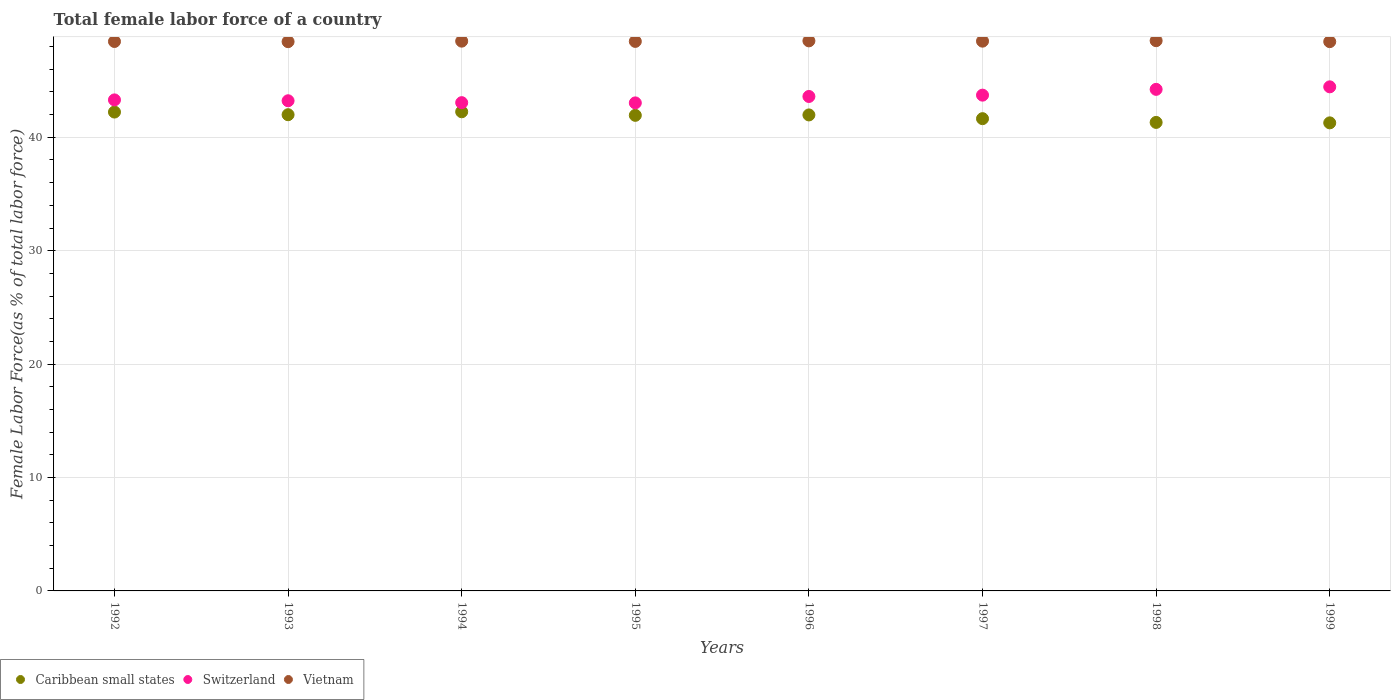Is the number of dotlines equal to the number of legend labels?
Make the answer very short. Yes. What is the percentage of female labor force in Caribbean small states in 1995?
Offer a terse response. 41.93. Across all years, what is the maximum percentage of female labor force in Caribbean small states?
Make the answer very short. 42.25. Across all years, what is the minimum percentage of female labor force in Caribbean small states?
Keep it short and to the point. 41.27. What is the total percentage of female labor force in Switzerland in the graph?
Make the answer very short. 348.59. What is the difference between the percentage of female labor force in Caribbean small states in 1993 and that in 1994?
Make the answer very short. -0.26. What is the difference between the percentage of female labor force in Vietnam in 1998 and the percentage of female labor force in Caribbean small states in 1996?
Ensure brevity in your answer.  6.55. What is the average percentage of female labor force in Vietnam per year?
Provide a succinct answer. 48.47. In the year 1995, what is the difference between the percentage of female labor force in Switzerland and percentage of female labor force in Vietnam?
Your answer should be very brief. -5.42. What is the ratio of the percentage of female labor force in Caribbean small states in 1998 to that in 1999?
Your answer should be compact. 1. What is the difference between the highest and the second highest percentage of female labor force in Vietnam?
Offer a terse response. 0.02. What is the difference between the highest and the lowest percentage of female labor force in Caribbean small states?
Provide a succinct answer. 0.98. In how many years, is the percentage of female labor force in Vietnam greater than the average percentage of female labor force in Vietnam taken over all years?
Your response must be concise. 4. Is the sum of the percentage of female labor force in Caribbean small states in 1992 and 1995 greater than the maximum percentage of female labor force in Vietnam across all years?
Your answer should be very brief. Yes. Is it the case that in every year, the sum of the percentage of female labor force in Vietnam and percentage of female labor force in Caribbean small states  is greater than the percentage of female labor force in Switzerland?
Offer a terse response. Yes. Is the percentage of female labor force in Switzerland strictly greater than the percentage of female labor force in Caribbean small states over the years?
Your response must be concise. Yes. Is the percentage of female labor force in Switzerland strictly less than the percentage of female labor force in Vietnam over the years?
Offer a very short reply. Yes. How many dotlines are there?
Your answer should be very brief. 3. What is the difference between two consecutive major ticks on the Y-axis?
Your answer should be very brief. 10. Are the values on the major ticks of Y-axis written in scientific E-notation?
Make the answer very short. No. Does the graph contain any zero values?
Keep it short and to the point. No. Does the graph contain grids?
Your answer should be compact. Yes. How many legend labels are there?
Provide a succinct answer. 3. What is the title of the graph?
Provide a short and direct response. Total female labor force of a country. What is the label or title of the Y-axis?
Ensure brevity in your answer.  Female Labor Force(as % of total labor force). What is the Female Labor Force(as % of total labor force) of Caribbean small states in 1992?
Provide a succinct answer. 42.22. What is the Female Labor Force(as % of total labor force) in Switzerland in 1992?
Provide a short and direct response. 43.3. What is the Female Labor Force(as % of total labor force) in Vietnam in 1992?
Ensure brevity in your answer.  48.45. What is the Female Labor Force(as % of total labor force) in Caribbean small states in 1993?
Offer a very short reply. 41.99. What is the Female Labor Force(as % of total labor force) in Switzerland in 1993?
Provide a short and direct response. 43.22. What is the Female Labor Force(as % of total labor force) of Vietnam in 1993?
Offer a very short reply. 48.43. What is the Female Labor Force(as % of total labor force) of Caribbean small states in 1994?
Your response must be concise. 42.25. What is the Female Labor Force(as % of total labor force) in Switzerland in 1994?
Keep it short and to the point. 43.05. What is the Female Labor Force(as % of total labor force) of Vietnam in 1994?
Make the answer very short. 48.48. What is the Female Labor Force(as % of total labor force) in Caribbean small states in 1995?
Make the answer very short. 41.93. What is the Female Labor Force(as % of total labor force) in Switzerland in 1995?
Offer a terse response. 43.03. What is the Female Labor Force(as % of total labor force) in Vietnam in 1995?
Offer a terse response. 48.45. What is the Female Labor Force(as % of total labor force) of Caribbean small states in 1996?
Give a very brief answer. 41.97. What is the Female Labor Force(as % of total labor force) of Switzerland in 1996?
Make the answer very short. 43.6. What is the Female Labor Force(as % of total labor force) of Vietnam in 1996?
Provide a succinct answer. 48.5. What is the Female Labor Force(as % of total labor force) of Caribbean small states in 1997?
Provide a succinct answer. 41.64. What is the Female Labor Force(as % of total labor force) in Switzerland in 1997?
Provide a succinct answer. 43.71. What is the Female Labor Force(as % of total labor force) in Vietnam in 1997?
Give a very brief answer. 48.48. What is the Female Labor Force(as % of total labor force) of Caribbean small states in 1998?
Offer a very short reply. 41.31. What is the Female Labor Force(as % of total labor force) of Switzerland in 1998?
Keep it short and to the point. 44.23. What is the Female Labor Force(as % of total labor force) of Vietnam in 1998?
Your answer should be very brief. 48.52. What is the Female Labor Force(as % of total labor force) in Caribbean small states in 1999?
Ensure brevity in your answer.  41.27. What is the Female Labor Force(as % of total labor force) of Switzerland in 1999?
Your answer should be compact. 44.45. What is the Female Labor Force(as % of total labor force) in Vietnam in 1999?
Provide a short and direct response. 48.43. Across all years, what is the maximum Female Labor Force(as % of total labor force) of Caribbean small states?
Your response must be concise. 42.25. Across all years, what is the maximum Female Labor Force(as % of total labor force) of Switzerland?
Ensure brevity in your answer.  44.45. Across all years, what is the maximum Female Labor Force(as % of total labor force) of Vietnam?
Give a very brief answer. 48.52. Across all years, what is the minimum Female Labor Force(as % of total labor force) of Caribbean small states?
Give a very brief answer. 41.27. Across all years, what is the minimum Female Labor Force(as % of total labor force) of Switzerland?
Your answer should be compact. 43.03. Across all years, what is the minimum Female Labor Force(as % of total labor force) of Vietnam?
Offer a terse response. 48.43. What is the total Female Labor Force(as % of total labor force) of Caribbean small states in the graph?
Your answer should be very brief. 334.59. What is the total Female Labor Force(as % of total labor force) in Switzerland in the graph?
Your answer should be compact. 348.59. What is the total Female Labor Force(as % of total labor force) in Vietnam in the graph?
Ensure brevity in your answer.  387.73. What is the difference between the Female Labor Force(as % of total labor force) of Caribbean small states in 1992 and that in 1993?
Keep it short and to the point. 0.23. What is the difference between the Female Labor Force(as % of total labor force) in Switzerland in 1992 and that in 1993?
Offer a very short reply. 0.08. What is the difference between the Female Labor Force(as % of total labor force) of Vietnam in 1992 and that in 1993?
Make the answer very short. 0.01. What is the difference between the Female Labor Force(as % of total labor force) of Caribbean small states in 1992 and that in 1994?
Make the answer very short. -0.03. What is the difference between the Female Labor Force(as % of total labor force) of Switzerland in 1992 and that in 1994?
Provide a short and direct response. 0.24. What is the difference between the Female Labor Force(as % of total labor force) in Vietnam in 1992 and that in 1994?
Your response must be concise. -0.03. What is the difference between the Female Labor Force(as % of total labor force) in Caribbean small states in 1992 and that in 1995?
Give a very brief answer. 0.29. What is the difference between the Female Labor Force(as % of total labor force) in Switzerland in 1992 and that in 1995?
Provide a short and direct response. 0.26. What is the difference between the Female Labor Force(as % of total labor force) in Vietnam in 1992 and that in 1995?
Your answer should be compact. -0.01. What is the difference between the Female Labor Force(as % of total labor force) of Caribbean small states in 1992 and that in 1996?
Ensure brevity in your answer.  0.25. What is the difference between the Female Labor Force(as % of total labor force) of Switzerland in 1992 and that in 1996?
Keep it short and to the point. -0.3. What is the difference between the Female Labor Force(as % of total labor force) of Vietnam in 1992 and that in 1996?
Your answer should be very brief. -0.05. What is the difference between the Female Labor Force(as % of total labor force) of Caribbean small states in 1992 and that in 1997?
Make the answer very short. 0.58. What is the difference between the Female Labor Force(as % of total labor force) of Switzerland in 1992 and that in 1997?
Make the answer very short. -0.42. What is the difference between the Female Labor Force(as % of total labor force) in Vietnam in 1992 and that in 1997?
Offer a terse response. -0.03. What is the difference between the Female Labor Force(as % of total labor force) of Caribbean small states in 1992 and that in 1998?
Make the answer very short. 0.91. What is the difference between the Female Labor Force(as % of total labor force) in Switzerland in 1992 and that in 1998?
Your response must be concise. -0.93. What is the difference between the Female Labor Force(as % of total labor force) in Vietnam in 1992 and that in 1998?
Ensure brevity in your answer.  -0.07. What is the difference between the Female Labor Force(as % of total labor force) in Caribbean small states in 1992 and that in 1999?
Your response must be concise. 0.95. What is the difference between the Female Labor Force(as % of total labor force) in Switzerland in 1992 and that in 1999?
Keep it short and to the point. -1.15. What is the difference between the Female Labor Force(as % of total labor force) in Vietnam in 1992 and that in 1999?
Provide a short and direct response. 0.01. What is the difference between the Female Labor Force(as % of total labor force) of Caribbean small states in 1993 and that in 1994?
Your answer should be compact. -0.26. What is the difference between the Female Labor Force(as % of total labor force) of Switzerland in 1993 and that in 1994?
Make the answer very short. 0.17. What is the difference between the Female Labor Force(as % of total labor force) of Vietnam in 1993 and that in 1994?
Provide a succinct answer. -0.05. What is the difference between the Female Labor Force(as % of total labor force) of Caribbean small states in 1993 and that in 1995?
Give a very brief answer. 0.06. What is the difference between the Female Labor Force(as % of total labor force) in Switzerland in 1993 and that in 1995?
Provide a succinct answer. 0.19. What is the difference between the Female Labor Force(as % of total labor force) in Vietnam in 1993 and that in 1995?
Your answer should be very brief. -0.02. What is the difference between the Female Labor Force(as % of total labor force) in Caribbean small states in 1993 and that in 1996?
Keep it short and to the point. 0.02. What is the difference between the Female Labor Force(as % of total labor force) of Switzerland in 1993 and that in 1996?
Your answer should be compact. -0.38. What is the difference between the Female Labor Force(as % of total labor force) of Vietnam in 1993 and that in 1996?
Your answer should be compact. -0.07. What is the difference between the Female Labor Force(as % of total labor force) of Caribbean small states in 1993 and that in 1997?
Offer a very short reply. 0.35. What is the difference between the Female Labor Force(as % of total labor force) of Switzerland in 1993 and that in 1997?
Your answer should be very brief. -0.5. What is the difference between the Female Labor Force(as % of total labor force) in Vietnam in 1993 and that in 1997?
Your answer should be very brief. -0.04. What is the difference between the Female Labor Force(as % of total labor force) in Caribbean small states in 1993 and that in 1998?
Provide a short and direct response. 0.68. What is the difference between the Female Labor Force(as % of total labor force) in Switzerland in 1993 and that in 1998?
Your response must be concise. -1.01. What is the difference between the Female Labor Force(as % of total labor force) in Vietnam in 1993 and that in 1998?
Keep it short and to the point. -0.09. What is the difference between the Female Labor Force(as % of total labor force) of Caribbean small states in 1993 and that in 1999?
Provide a succinct answer. 0.72. What is the difference between the Female Labor Force(as % of total labor force) in Switzerland in 1993 and that in 1999?
Offer a terse response. -1.23. What is the difference between the Female Labor Force(as % of total labor force) of Vietnam in 1993 and that in 1999?
Your response must be concise. -0. What is the difference between the Female Labor Force(as % of total labor force) of Caribbean small states in 1994 and that in 1995?
Provide a succinct answer. 0.31. What is the difference between the Female Labor Force(as % of total labor force) of Switzerland in 1994 and that in 1995?
Give a very brief answer. 0.02. What is the difference between the Female Labor Force(as % of total labor force) in Vietnam in 1994 and that in 1995?
Your response must be concise. 0.02. What is the difference between the Female Labor Force(as % of total labor force) of Caribbean small states in 1994 and that in 1996?
Your answer should be compact. 0.28. What is the difference between the Female Labor Force(as % of total labor force) of Switzerland in 1994 and that in 1996?
Provide a succinct answer. -0.55. What is the difference between the Female Labor Force(as % of total labor force) of Vietnam in 1994 and that in 1996?
Give a very brief answer. -0.02. What is the difference between the Female Labor Force(as % of total labor force) of Caribbean small states in 1994 and that in 1997?
Offer a very short reply. 0.61. What is the difference between the Female Labor Force(as % of total labor force) in Switzerland in 1994 and that in 1997?
Keep it short and to the point. -0.66. What is the difference between the Female Labor Force(as % of total labor force) of Vietnam in 1994 and that in 1997?
Keep it short and to the point. 0. What is the difference between the Female Labor Force(as % of total labor force) in Caribbean small states in 1994 and that in 1998?
Give a very brief answer. 0.94. What is the difference between the Female Labor Force(as % of total labor force) of Switzerland in 1994 and that in 1998?
Provide a short and direct response. -1.17. What is the difference between the Female Labor Force(as % of total labor force) of Vietnam in 1994 and that in 1998?
Your response must be concise. -0.04. What is the difference between the Female Labor Force(as % of total labor force) of Caribbean small states in 1994 and that in 1999?
Give a very brief answer. 0.98. What is the difference between the Female Labor Force(as % of total labor force) in Switzerland in 1994 and that in 1999?
Your response must be concise. -1.4. What is the difference between the Female Labor Force(as % of total labor force) in Vietnam in 1994 and that in 1999?
Your answer should be very brief. 0.04. What is the difference between the Female Labor Force(as % of total labor force) of Caribbean small states in 1995 and that in 1996?
Your answer should be very brief. -0.04. What is the difference between the Female Labor Force(as % of total labor force) of Switzerland in 1995 and that in 1996?
Make the answer very short. -0.57. What is the difference between the Female Labor Force(as % of total labor force) in Vietnam in 1995 and that in 1996?
Offer a very short reply. -0.05. What is the difference between the Female Labor Force(as % of total labor force) in Caribbean small states in 1995 and that in 1997?
Provide a succinct answer. 0.29. What is the difference between the Female Labor Force(as % of total labor force) in Switzerland in 1995 and that in 1997?
Your answer should be compact. -0.68. What is the difference between the Female Labor Force(as % of total labor force) in Vietnam in 1995 and that in 1997?
Provide a short and direct response. -0.02. What is the difference between the Female Labor Force(as % of total labor force) in Caribbean small states in 1995 and that in 1998?
Ensure brevity in your answer.  0.62. What is the difference between the Female Labor Force(as % of total labor force) in Switzerland in 1995 and that in 1998?
Provide a short and direct response. -1.19. What is the difference between the Female Labor Force(as % of total labor force) of Vietnam in 1995 and that in 1998?
Your answer should be very brief. -0.06. What is the difference between the Female Labor Force(as % of total labor force) in Caribbean small states in 1995 and that in 1999?
Keep it short and to the point. 0.66. What is the difference between the Female Labor Force(as % of total labor force) of Switzerland in 1995 and that in 1999?
Offer a terse response. -1.42. What is the difference between the Female Labor Force(as % of total labor force) of Vietnam in 1995 and that in 1999?
Offer a very short reply. 0.02. What is the difference between the Female Labor Force(as % of total labor force) of Caribbean small states in 1996 and that in 1997?
Your answer should be very brief. 0.33. What is the difference between the Female Labor Force(as % of total labor force) of Switzerland in 1996 and that in 1997?
Your answer should be compact. -0.12. What is the difference between the Female Labor Force(as % of total labor force) in Vietnam in 1996 and that in 1997?
Ensure brevity in your answer.  0.03. What is the difference between the Female Labor Force(as % of total labor force) of Caribbean small states in 1996 and that in 1998?
Ensure brevity in your answer.  0.66. What is the difference between the Female Labor Force(as % of total labor force) of Switzerland in 1996 and that in 1998?
Ensure brevity in your answer.  -0.63. What is the difference between the Female Labor Force(as % of total labor force) of Vietnam in 1996 and that in 1998?
Your response must be concise. -0.02. What is the difference between the Female Labor Force(as % of total labor force) of Caribbean small states in 1996 and that in 1999?
Give a very brief answer. 0.7. What is the difference between the Female Labor Force(as % of total labor force) of Switzerland in 1996 and that in 1999?
Make the answer very short. -0.85. What is the difference between the Female Labor Force(as % of total labor force) of Vietnam in 1996 and that in 1999?
Your answer should be compact. 0.07. What is the difference between the Female Labor Force(as % of total labor force) of Caribbean small states in 1997 and that in 1998?
Offer a very short reply. 0.33. What is the difference between the Female Labor Force(as % of total labor force) of Switzerland in 1997 and that in 1998?
Your response must be concise. -0.51. What is the difference between the Female Labor Force(as % of total labor force) in Vietnam in 1997 and that in 1998?
Provide a short and direct response. -0.04. What is the difference between the Female Labor Force(as % of total labor force) in Caribbean small states in 1997 and that in 1999?
Make the answer very short. 0.37. What is the difference between the Female Labor Force(as % of total labor force) of Switzerland in 1997 and that in 1999?
Your response must be concise. -0.73. What is the difference between the Female Labor Force(as % of total labor force) in Vietnam in 1997 and that in 1999?
Provide a short and direct response. 0.04. What is the difference between the Female Labor Force(as % of total labor force) of Caribbean small states in 1998 and that in 1999?
Keep it short and to the point. 0.04. What is the difference between the Female Labor Force(as % of total labor force) of Switzerland in 1998 and that in 1999?
Give a very brief answer. -0.22. What is the difference between the Female Labor Force(as % of total labor force) in Vietnam in 1998 and that in 1999?
Offer a terse response. 0.09. What is the difference between the Female Labor Force(as % of total labor force) in Caribbean small states in 1992 and the Female Labor Force(as % of total labor force) in Switzerland in 1993?
Your answer should be compact. -1. What is the difference between the Female Labor Force(as % of total labor force) of Caribbean small states in 1992 and the Female Labor Force(as % of total labor force) of Vietnam in 1993?
Your response must be concise. -6.21. What is the difference between the Female Labor Force(as % of total labor force) of Switzerland in 1992 and the Female Labor Force(as % of total labor force) of Vietnam in 1993?
Provide a short and direct response. -5.13. What is the difference between the Female Labor Force(as % of total labor force) in Caribbean small states in 1992 and the Female Labor Force(as % of total labor force) in Switzerland in 1994?
Offer a very short reply. -0.83. What is the difference between the Female Labor Force(as % of total labor force) in Caribbean small states in 1992 and the Female Labor Force(as % of total labor force) in Vietnam in 1994?
Ensure brevity in your answer.  -6.25. What is the difference between the Female Labor Force(as % of total labor force) in Switzerland in 1992 and the Female Labor Force(as % of total labor force) in Vietnam in 1994?
Your answer should be compact. -5.18. What is the difference between the Female Labor Force(as % of total labor force) of Caribbean small states in 1992 and the Female Labor Force(as % of total labor force) of Switzerland in 1995?
Your response must be concise. -0.81. What is the difference between the Female Labor Force(as % of total labor force) of Caribbean small states in 1992 and the Female Labor Force(as % of total labor force) of Vietnam in 1995?
Your answer should be very brief. -6.23. What is the difference between the Female Labor Force(as % of total labor force) of Switzerland in 1992 and the Female Labor Force(as % of total labor force) of Vietnam in 1995?
Offer a terse response. -5.16. What is the difference between the Female Labor Force(as % of total labor force) in Caribbean small states in 1992 and the Female Labor Force(as % of total labor force) in Switzerland in 1996?
Offer a terse response. -1.37. What is the difference between the Female Labor Force(as % of total labor force) of Caribbean small states in 1992 and the Female Labor Force(as % of total labor force) of Vietnam in 1996?
Provide a succinct answer. -6.28. What is the difference between the Female Labor Force(as % of total labor force) in Switzerland in 1992 and the Female Labor Force(as % of total labor force) in Vietnam in 1996?
Provide a succinct answer. -5.2. What is the difference between the Female Labor Force(as % of total labor force) of Caribbean small states in 1992 and the Female Labor Force(as % of total labor force) of Switzerland in 1997?
Keep it short and to the point. -1.49. What is the difference between the Female Labor Force(as % of total labor force) in Caribbean small states in 1992 and the Female Labor Force(as % of total labor force) in Vietnam in 1997?
Make the answer very short. -6.25. What is the difference between the Female Labor Force(as % of total labor force) of Switzerland in 1992 and the Female Labor Force(as % of total labor force) of Vietnam in 1997?
Your answer should be very brief. -5.18. What is the difference between the Female Labor Force(as % of total labor force) in Caribbean small states in 1992 and the Female Labor Force(as % of total labor force) in Switzerland in 1998?
Keep it short and to the point. -2. What is the difference between the Female Labor Force(as % of total labor force) of Caribbean small states in 1992 and the Female Labor Force(as % of total labor force) of Vietnam in 1998?
Provide a short and direct response. -6.29. What is the difference between the Female Labor Force(as % of total labor force) in Switzerland in 1992 and the Female Labor Force(as % of total labor force) in Vietnam in 1998?
Keep it short and to the point. -5.22. What is the difference between the Female Labor Force(as % of total labor force) of Caribbean small states in 1992 and the Female Labor Force(as % of total labor force) of Switzerland in 1999?
Offer a very short reply. -2.22. What is the difference between the Female Labor Force(as % of total labor force) in Caribbean small states in 1992 and the Female Labor Force(as % of total labor force) in Vietnam in 1999?
Offer a very short reply. -6.21. What is the difference between the Female Labor Force(as % of total labor force) in Switzerland in 1992 and the Female Labor Force(as % of total labor force) in Vietnam in 1999?
Give a very brief answer. -5.14. What is the difference between the Female Labor Force(as % of total labor force) in Caribbean small states in 1993 and the Female Labor Force(as % of total labor force) in Switzerland in 1994?
Ensure brevity in your answer.  -1.06. What is the difference between the Female Labor Force(as % of total labor force) in Caribbean small states in 1993 and the Female Labor Force(as % of total labor force) in Vietnam in 1994?
Ensure brevity in your answer.  -6.49. What is the difference between the Female Labor Force(as % of total labor force) of Switzerland in 1993 and the Female Labor Force(as % of total labor force) of Vietnam in 1994?
Provide a succinct answer. -5.26. What is the difference between the Female Labor Force(as % of total labor force) of Caribbean small states in 1993 and the Female Labor Force(as % of total labor force) of Switzerland in 1995?
Ensure brevity in your answer.  -1.04. What is the difference between the Female Labor Force(as % of total labor force) in Caribbean small states in 1993 and the Female Labor Force(as % of total labor force) in Vietnam in 1995?
Offer a terse response. -6.46. What is the difference between the Female Labor Force(as % of total labor force) of Switzerland in 1993 and the Female Labor Force(as % of total labor force) of Vietnam in 1995?
Your response must be concise. -5.23. What is the difference between the Female Labor Force(as % of total labor force) of Caribbean small states in 1993 and the Female Labor Force(as % of total labor force) of Switzerland in 1996?
Give a very brief answer. -1.61. What is the difference between the Female Labor Force(as % of total labor force) of Caribbean small states in 1993 and the Female Labor Force(as % of total labor force) of Vietnam in 1996?
Offer a terse response. -6.51. What is the difference between the Female Labor Force(as % of total labor force) of Switzerland in 1993 and the Female Labor Force(as % of total labor force) of Vietnam in 1996?
Your answer should be compact. -5.28. What is the difference between the Female Labor Force(as % of total labor force) in Caribbean small states in 1993 and the Female Labor Force(as % of total labor force) in Switzerland in 1997?
Your answer should be compact. -1.72. What is the difference between the Female Labor Force(as % of total labor force) in Caribbean small states in 1993 and the Female Labor Force(as % of total labor force) in Vietnam in 1997?
Provide a succinct answer. -6.49. What is the difference between the Female Labor Force(as % of total labor force) in Switzerland in 1993 and the Female Labor Force(as % of total labor force) in Vietnam in 1997?
Your answer should be very brief. -5.26. What is the difference between the Female Labor Force(as % of total labor force) of Caribbean small states in 1993 and the Female Labor Force(as % of total labor force) of Switzerland in 1998?
Provide a succinct answer. -2.24. What is the difference between the Female Labor Force(as % of total labor force) in Caribbean small states in 1993 and the Female Labor Force(as % of total labor force) in Vietnam in 1998?
Offer a terse response. -6.53. What is the difference between the Female Labor Force(as % of total labor force) of Switzerland in 1993 and the Female Labor Force(as % of total labor force) of Vietnam in 1998?
Your response must be concise. -5.3. What is the difference between the Female Labor Force(as % of total labor force) in Caribbean small states in 1993 and the Female Labor Force(as % of total labor force) in Switzerland in 1999?
Your response must be concise. -2.46. What is the difference between the Female Labor Force(as % of total labor force) in Caribbean small states in 1993 and the Female Labor Force(as % of total labor force) in Vietnam in 1999?
Keep it short and to the point. -6.44. What is the difference between the Female Labor Force(as % of total labor force) in Switzerland in 1993 and the Female Labor Force(as % of total labor force) in Vietnam in 1999?
Provide a succinct answer. -5.21. What is the difference between the Female Labor Force(as % of total labor force) of Caribbean small states in 1994 and the Female Labor Force(as % of total labor force) of Switzerland in 1995?
Your response must be concise. -0.78. What is the difference between the Female Labor Force(as % of total labor force) in Caribbean small states in 1994 and the Female Labor Force(as % of total labor force) in Vietnam in 1995?
Your response must be concise. -6.2. What is the difference between the Female Labor Force(as % of total labor force) of Switzerland in 1994 and the Female Labor Force(as % of total labor force) of Vietnam in 1995?
Make the answer very short. -5.4. What is the difference between the Female Labor Force(as % of total labor force) of Caribbean small states in 1994 and the Female Labor Force(as % of total labor force) of Switzerland in 1996?
Ensure brevity in your answer.  -1.35. What is the difference between the Female Labor Force(as % of total labor force) in Caribbean small states in 1994 and the Female Labor Force(as % of total labor force) in Vietnam in 1996?
Provide a succinct answer. -6.25. What is the difference between the Female Labor Force(as % of total labor force) of Switzerland in 1994 and the Female Labor Force(as % of total labor force) of Vietnam in 1996?
Offer a terse response. -5.45. What is the difference between the Female Labor Force(as % of total labor force) of Caribbean small states in 1994 and the Female Labor Force(as % of total labor force) of Switzerland in 1997?
Your answer should be compact. -1.47. What is the difference between the Female Labor Force(as % of total labor force) in Caribbean small states in 1994 and the Female Labor Force(as % of total labor force) in Vietnam in 1997?
Your answer should be compact. -6.23. What is the difference between the Female Labor Force(as % of total labor force) in Switzerland in 1994 and the Female Labor Force(as % of total labor force) in Vietnam in 1997?
Make the answer very short. -5.42. What is the difference between the Female Labor Force(as % of total labor force) of Caribbean small states in 1994 and the Female Labor Force(as % of total labor force) of Switzerland in 1998?
Provide a succinct answer. -1.98. What is the difference between the Female Labor Force(as % of total labor force) in Caribbean small states in 1994 and the Female Labor Force(as % of total labor force) in Vietnam in 1998?
Offer a terse response. -6.27. What is the difference between the Female Labor Force(as % of total labor force) in Switzerland in 1994 and the Female Labor Force(as % of total labor force) in Vietnam in 1998?
Keep it short and to the point. -5.46. What is the difference between the Female Labor Force(as % of total labor force) of Caribbean small states in 1994 and the Female Labor Force(as % of total labor force) of Switzerland in 1999?
Provide a short and direct response. -2.2. What is the difference between the Female Labor Force(as % of total labor force) in Caribbean small states in 1994 and the Female Labor Force(as % of total labor force) in Vietnam in 1999?
Your answer should be compact. -6.18. What is the difference between the Female Labor Force(as % of total labor force) of Switzerland in 1994 and the Female Labor Force(as % of total labor force) of Vietnam in 1999?
Give a very brief answer. -5.38. What is the difference between the Female Labor Force(as % of total labor force) of Caribbean small states in 1995 and the Female Labor Force(as % of total labor force) of Switzerland in 1996?
Your answer should be compact. -1.66. What is the difference between the Female Labor Force(as % of total labor force) of Caribbean small states in 1995 and the Female Labor Force(as % of total labor force) of Vietnam in 1996?
Provide a short and direct response. -6.57. What is the difference between the Female Labor Force(as % of total labor force) in Switzerland in 1995 and the Female Labor Force(as % of total labor force) in Vietnam in 1996?
Offer a terse response. -5.47. What is the difference between the Female Labor Force(as % of total labor force) in Caribbean small states in 1995 and the Female Labor Force(as % of total labor force) in Switzerland in 1997?
Provide a short and direct response. -1.78. What is the difference between the Female Labor Force(as % of total labor force) in Caribbean small states in 1995 and the Female Labor Force(as % of total labor force) in Vietnam in 1997?
Offer a very short reply. -6.54. What is the difference between the Female Labor Force(as % of total labor force) in Switzerland in 1995 and the Female Labor Force(as % of total labor force) in Vietnam in 1997?
Ensure brevity in your answer.  -5.44. What is the difference between the Female Labor Force(as % of total labor force) in Caribbean small states in 1995 and the Female Labor Force(as % of total labor force) in Switzerland in 1998?
Make the answer very short. -2.29. What is the difference between the Female Labor Force(as % of total labor force) of Caribbean small states in 1995 and the Female Labor Force(as % of total labor force) of Vietnam in 1998?
Offer a very short reply. -6.58. What is the difference between the Female Labor Force(as % of total labor force) in Switzerland in 1995 and the Female Labor Force(as % of total labor force) in Vietnam in 1998?
Make the answer very short. -5.49. What is the difference between the Female Labor Force(as % of total labor force) in Caribbean small states in 1995 and the Female Labor Force(as % of total labor force) in Switzerland in 1999?
Your answer should be compact. -2.51. What is the difference between the Female Labor Force(as % of total labor force) of Caribbean small states in 1995 and the Female Labor Force(as % of total labor force) of Vietnam in 1999?
Offer a terse response. -6.5. What is the difference between the Female Labor Force(as % of total labor force) of Switzerland in 1995 and the Female Labor Force(as % of total labor force) of Vietnam in 1999?
Your response must be concise. -5.4. What is the difference between the Female Labor Force(as % of total labor force) in Caribbean small states in 1996 and the Female Labor Force(as % of total labor force) in Switzerland in 1997?
Your answer should be compact. -1.74. What is the difference between the Female Labor Force(as % of total labor force) in Caribbean small states in 1996 and the Female Labor Force(as % of total labor force) in Vietnam in 1997?
Your answer should be compact. -6.5. What is the difference between the Female Labor Force(as % of total labor force) of Switzerland in 1996 and the Female Labor Force(as % of total labor force) of Vietnam in 1997?
Your response must be concise. -4.88. What is the difference between the Female Labor Force(as % of total labor force) of Caribbean small states in 1996 and the Female Labor Force(as % of total labor force) of Switzerland in 1998?
Provide a succinct answer. -2.26. What is the difference between the Female Labor Force(as % of total labor force) in Caribbean small states in 1996 and the Female Labor Force(as % of total labor force) in Vietnam in 1998?
Make the answer very short. -6.55. What is the difference between the Female Labor Force(as % of total labor force) of Switzerland in 1996 and the Female Labor Force(as % of total labor force) of Vietnam in 1998?
Your answer should be very brief. -4.92. What is the difference between the Female Labor Force(as % of total labor force) of Caribbean small states in 1996 and the Female Labor Force(as % of total labor force) of Switzerland in 1999?
Keep it short and to the point. -2.48. What is the difference between the Female Labor Force(as % of total labor force) in Caribbean small states in 1996 and the Female Labor Force(as % of total labor force) in Vietnam in 1999?
Your answer should be compact. -6.46. What is the difference between the Female Labor Force(as % of total labor force) of Switzerland in 1996 and the Female Labor Force(as % of total labor force) of Vietnam in 1999?
Provide a succinct answer. -4.83. What is the difference between the Female Labor Force(as % of total labor force) of Caribbean small states in 1997 and the Female Labor Force(as % of total labor force) of Switzerland in 1998?
Ensure brevity in your answer.  -2.58. What is the difference between the Female Labor Force(as % of total labor force) of Caribbean small states in 1997 and the Female Labor Force(as % of total labor force) of Vietnam in 1998?
Keep it short and to the point. -6.88. What is the difference between the Female Labor Force(as % of total labor force) in Switzerland in 1997 and the Female Labor Force(as % of total labor force) in Vietnam in 1998?
Provide a succinct answer. -4.8. What is the difference between the Female Labor Force(as % of total labor force) in Caribbean small states in 1997 and the Female Labor Force(as % of total labor force) in Switzerland in 1999?
Your answer should be compact. -2.81. What is the difference between the Female Labor Force(as % of total labor force) in Caribbean small states in 1997 and the Female Labor Force(as % of total labor force) in Vietnam in 1999?
Your answer should be very brief. -6.79. What is the difference between the Female Labor Force(as % of total labor force) of Switzerland in 1997 and the Female Labor Force(as % of total labor force) of Vietnam in 1999?
Ensure brevity in your answer.  -4.72. What is the difference between the Female Labor Force(as % of total labor force) in Caribbean small states in 1998 and the Female Labor Force(as % of total labor force) in Switzerland in 1999?
Provide a short and direct response. -3.14. What is the difference between the Female Labor Force(as % of total labor force) in Caribbean small states in 1998 and the Female Labor Force(as % of total labor force) in Vietnam in 1999?
Offer a terse response. -7.12. What is the difference between the Female Labor Force(as % of total labor force) of Switzerland in 1998 and the Female Labor Force(as % of total labor force) of Vietnam in 1999?
Make the answer very short. -4.21. What is the average Female Labor Force(as % of total labor force) of Caribbean small states per year?
Make the answer very short. 41.82. What is the average Female Labor Force(as % of total labor force) of Switzerland per year?
Keep it short and to the point. 43.57. What is the average Female Labor Force(as % of total labor force) in Vietnam per year?
Provide a succinct answer. 48.47. In the year 1992, what is the difference between the Female Labor Force(as % of total labor force) of Caribbean small states and Female Labor Force(as % of total labor force) of Switzerland?
Provide a short and direct response. -1.07. In the year 1992, what is the difference between the Female Labor Force(as % of total labor force) in Caribbean small states and Female Labor Force(as % of total labor force) in Vietnam?
Keep it short and to the point. -6.22. In the year 1992, what is the difference between the Female Labor Force(as % of total labor force) in Switzerland and Female Labor Force(as % of total labor force) in Vietnam?
Your response must be concise. -5.15. In the year 1993, what is the difference between the Female Labor Force(as % of total labor force) of Caribbean small states and Female Labor Force(as % of total labor force) of Switzerland?
Keep it short and to the point. -1.23. In the year 1993, what is the difference between the Female Labor Force(as % of total labor force) of Caribbean small states and Female Labor Force(as % of total labor force) of Vietnam?
Your answer should be compact. -6.44. In the year 1993, what is the difference between the Female Labor Force(as % of total labor force) of Switzerland and Female Labor Force(as % of total labor force) of Vietnam?
Keep it short and to the point. -5.21. In the year 1994, what is the difference between the Female Labor Force(as % of total labor force) of Caribbean small states and Female Labor Force(as % of total labor force) of Switzerland?
Make the answer very short. -0.8. In the year 1994, what is the difference between the Female Labor Force(as % of total labor force) of Caribbean small states and Female Labor Force(as % of total labor force) of Vietnam?
Provide a succinct answer. -6.23. In the year 1994, what is the difference between the Female Labor Force(as % of total labor force) of Switzerland and Female Labor Force(as % of total labor force) of Vietnam?
Ensure brevity in your answer.  -5.42. In the year 1995, what is the difference between the Female Labor Force(as % of total labor force) in Caribbean small states and Female Labor Force(as % of total labor force) in Switzerland?
Give a very brief answer. -1.1. In the year 1995, what is the difference between the Female Labor Force(as % of total labor force) in Caribbean small states and Female Labor Force(as % of total labor force) in Vietnam?
Ensure brevity in your answer.  -6.52. In the year 1995, what is the difference between the Female Labor Force(as % of total labor force) of Switzerland and Female Labor Force(as % of total labor force) of Vietnam?
Your response must be concise. -5.42. In the year 1996, what is the difference between the Female Labor Force(as % of total labor force) in Caribbean small states and Female Labor Force(as % of total labor force) in Switzerland?
Your answer should be very brief. -1.63. In the year 1996, what is the difference between the Female Labor Force(as % of total labor force) in Caribbean small states and Female Labor Force(as % of total labor force) in Vietnam?
Keep it short and to the point. -6.53. In the year 1996, what is the difference between the Female Labor Force(as % of total labor force) in Switzerland and Female Labor Force(as % of total labor force) in Vietnam?
Your answer should be very brief. -4.9. In the year 1997, what is the difference between the Female Labor Force(as % of total labor force) in Caribbean small states and Female Labor Force(as % of total labor force) in Switzerland?
Provide a succinct answer. -2.07. In the year 1997, what is the difference between the Female Labor Force(as % of total labor force) in Caribbean small states and Female Labor Force(as % of total labor force) in Vietnam?
Offer a very short reply. -6.83. In the year 1997, what is the difference between the Female Labor Force(as % of total labor force) in Switzerland and Female Labor Force(as % of total labor force) in Vietnam?
Make the answer very short. -4.76. In the year 1998, what is the difference between the Female Labor Force(as % of total labor force) in Caribbean small states and Female Labor Force(as % of total labor force) in Switzerland?
Your response must be concise. -2.92. In the year 1998, what is the difference between the Female Labor Force(as % of total labor force) of Caribbean small states and Female Labor Force(as % of total labor force) of Vietnam?
Keep it short and to the point. -7.21. In the year 1998, what is the difference between the Female Labor Force(as % of total labor force) in Switzerland and Female Labor Force(as % of total labor force) in Vietnam?
Provide a short and direct response. -4.29. In the year 1999, what is the difference between the Female Labor Force(as % of total labor force) of Caribbean small states and Female Labor Force(as % of total labor force) of Switzerland?
Keep it short and to the point. -3.18. In the year 1999, what is the difference between the Female Labor Force(as % of total labor force) of Caribbean small states and Female Labor Force(as % of total labor force) of Vietnam?
Make the answer very short. -7.16. In the year 1999, what is the difference between the Female Labor Force(as % of total labor force) in Switzerland and Female Labor Force(as % of total labor force) in Vietnam?
Your answer should be compact. -3.98. What is the ratio of the Female Labor Force(as % of total labor force) in Caribbean small states in 1992 to that in 1993?
Provide a succinct answer. 1.01. What is the ratio of the Female Labor Force(as % of total labor force) in Switzerland in 1992 to that in 1993?
Provide a short and direct response. 1. What is the ratio of the Female Labor Force(as % of total labor force) of Vietnam in 1992 to that in 1993?
Offer a very short reply. 1. What is the ratio of the Female Labor Force(as % of total labor force) in Caribbean small states in 1992 to that in 1994?
Offer a terse response. 1. What is the ratio of the Female Labor Force(as % of total labor force) in Switzerland in 1992 to that in 1994?
Offer a terse response. 1.01. What is the ratio of the Female Labor Force(as % of total labor force) of Vietnam in 1992 to that in 1994?
Your response must be concise. 1. What is the ratio of the Female Labor Force(as % of total labor force) in Switzerland in 1992 to that in 1995?
Your answer should be very brief. 1.01. What is the ratio of the Female Labor Force(as % of total labor force) of Switzerland in 1992 to that in 1996?
Give a very brief answer. 0.99. What is the ratio of the Female Labor Force(as % of total labor force) of Vietnam in 1992 to that in 1996?
Your answer should be compact. 1. What is the ratio of the Female Labor Force(as % of total labor force) in Switzerland in 1992 to that in 1997?
Make the answer very short. 0.99. What is the ratio of the Female Labor Force(as % of total labor force) in Vietnam in 1992 to that in 1997?
Your answer should be very brief. 1. What is the ratio of the Female Labor Force(as % of total labor force) in Caribbean small states in 1992 to that in 1998?
Offer a terse response. 1.02. What is the ratio of the Female Labor Force(as % of total labor force) in Switzerland in 1992 to that in 1998?
Ensure brevity in your answer.  0.98. What is the ratio of the Female Labor Force(as % of total labor force) of Vietnam in 1992 to that in 1998?
Keep it short and to the point. 1. What is the ratio of the Female Labor Force(as % of total labor force) in Caribbean small states in 1992 to that in 1999?
Keep it short and to the point. 1.02. What is the ratio of the Female Labor Force(as % of total labor force) in Switzerland in 1992 to that in 1999?
Your response must be concise. 0.97. What is the ratio of the Female Labor Force(as % of total labor force) in Caribbean small states in 1993 to that in 1994?
Provide a short and direct response. 0.99. What is the ratio of the Female Labor Force(as % of total labor force) of Switzerland in 1993 to that in 1994?
Make the answer very short. 1. What is the ratio of the Female Labor Force(as % of total labor force) in Vietnam in 1993 to that in 1994?
Keep it short and to the point. 1. What is the ratio of the Female Labor Force(as % of total labor force) in Caribbean small states in 1993 to that in 1995?
Provide a short and direct response. 1. What is the ratio of the Female Labor Force(as % of total labor force) of Vietnam in 1993 to that in 1995?
Make the answer very short. 1. What is the ratio of the Female Labor Force(as % of total labor force) of Caribbean small states in 1993 to that in 1996?
Keep it short and to the point. 1. What is the ratio of the Female Labor Force(as % of total labor force) of Vietnam in 1993 to that in 1996?
Your answer should be very brief. 1. What is the ratio of the Female Labor Force(as % of total labor force) in Caribbean small states in 1993 to that in 1997?
Keep it short and to the point. 1.01. What is the ratio of the Female Labor Force(as % of total labor force) of Switzerland in 1993 to that in 1997?
Provide a succinct answer. 0.99. What is the ratio of the Female Labor Force(as % of total labor force) in Vietnam in 1993 to that in 1997?
Give a very brief answer. 1. What is the ratio of the Female Labor Force(as % of total labor force) of Caribbean small states in 1993 to that in 1998?
Provide a short and direct response. 1.02. What is the ratio of the Female Labor Force(as % of total labor force) in Switzerland in 1993 to that in 1998?
Provide a succinct answer. 0.98. What is the ratio of the Female Labor Force(as % of total labor force) of Caribbean small states in 1993 to that in 1999?
Your response must be concise. 1.02. What is the ratio of the Female Labor Force(as % of total labor force) in Switzerland in 1993 to that in 1999?
Your answer should be compact. 0.97. What is the ratio of the Female Labor Force(as % of total labor force) of Caribbean small states in 1994 to that in 1995?
Your response must be concise. 1.01. What is the ratio of the Female Labor Force(as % of total labor force) of Switzerland in 1994 to that in 1995?
Offer a terse response. 1. What is the ratio of the Female Labor Force(as % of total labor force) in Vietnam in 1994 to that in 1995?
Offer a very short reply. 1. What is the ratio of the Female Labor Force(as % of total labor force) of Caribbean small states in 1994 to that in 1996?
Keep it short and to the point. 1.01. What is the ratio of the Female Labor Force(as % of total labor force) in Switzerland in 1994 to that in 1996?
Ensure brevity in your answer.  0.99. What is the ratio of the Female Labor Force(as % of total labor force) of Vietnam in 1994 to that in 1996?
Offer a very short reply. 1. What is the ratio of the Female Labor Force(as % of total labor force) in Caribbean small states in 1994 to that in 1997?
Your answer should be compact. 1.01. What is the ratio of the Female Labor Force(as % of total labor force) of Caribbean small states in 1994 to that in 1998?
Your response must be concise. 1.02. What is the ratio of the Female Labor Force(as % of total labor force) in Switzerland in 1994 to that in 1998?
Make the answer very short. 0.97. What is the ratio of the Female Labor Force(as % of total labor force) in Caribbean small states in 1994 to that in 1999?
Offer a very short reply. 1.02. What is the ratio of the Female Labor Force(as % of total labor force) of Switzerland in 1994 to that in 1999?
Provide a succinct answer. 0.97. What is the ratio of the Female Labor Force(as % of total labor force) in Caribbean small states in 1995 to that in 1996?
Give a very brief answer. 1. What is the ratio of the Female Labor Force(as % of total labor force) of Vietnam in 1995 to that in 1996?
Offer a very short reply. 1. What is the ratio of the Female Labor Force(as % of total labor force) of Switzerland in 1995 to that in 1997?
Your answer should be very brief. 0.98. What is the ratio of the Female Labor Force(as % of total labor force) of Caribbean small states in 1995 to that in 1998?
Your answer should be very brief. 1.02. What is the ratio of the Female Labor Force(as % of total labor force) in Switzerland in 1995 to that in 1998?
Give a very brief answer. 0.97. What is the ratio of the Female Labor Force(as % of total labor force) in Caribbean small states in 1995 to that in 1999?
Your response must be concise. 1.02. What is the ratio of the Female Labor Force(as % of total labor force) of Switzerland in 1995 to that in 1999?
Keep it short and to the point. 0.97. What is the ratio of the Female Labor Force(as % of total labor force) of Caribbean small states in 1996 to that in 1997?
Provide a succinct answer. 1.01. What is the ratio of the Female Labor Force(as % of total labor force) of Vietnam in 1996 to that in 1997?
Give a very brief answer. 1. What is the ratio of the Female Labor Force(as % of total labor force) of Caribbean small states in 1996 to that in 1998?
Offer a terse response. 1.02. What is the ratio of the Female Labor Force(as % of total labor force) in Switzerland in 1996 to that in 1998?
Offer a terse response. 0.99. What is the ratio of the Female Labor Force(as % of total labor force) in Vietnam in 1996 to that in 1998?
Give a very brief answer. 1. What is the ratio of the Female Labor Force(as % of total labor force) in Caribbean small states in 1996 to that in 1999?
Make the answer very short. 1.02. What is the ratio of the Female Labor Force(as % of total labor force) of Switzerland in 1996 to that in 1999?
Make the answer very short. 0.98. What is the ratio of the Female Labor Force(as % of total labor force) of Vietnam in 1996 to that in 1999?
Keep it short and to the point. 1. What is the ratio of the Female Labor Force(as % of total labor force) in Switzerland in 1997 to that in 1998?
Provide a short and direct response. 0.99. What is the ratio of the Female Labor Force(as % of total labor force) of Vietnam in 1997 to that in 1998?
Give a very brief answer. 1. What is the ratio of the Female Labor Force(as % of total labor force) in Switzerland in 1997 to that in 1999?
Provide a succinct answer. 0.98. What is the ratio of the Female Labor Force(as % of total labor force) in Vietnam in 1997 to that in 1999?
Your response must be concise. 1. What is the difference between the highest and the second highest Female Labor Force(as % of total labor force) in Caribbean small states?
Your answer should be compact. 0.03. What is the difference between the highest and the second highest Female Labor Force(as % of total labor force) of Switzerland?
Give a very brief answer. 0.22. What is the difference between the highest and the second highest Female Labor Force(as % of total labor force) of Vietnam?
Keep it short and to the point. 0.02. What is the difference between the highest and the lowest Female Labor Force(as % of total labor force) in Caribbean small states?
Your answer should be compact. 0.98. What is the difference between the highest and the lowest Female Labor Force(as % of total labor force) of Switzerland?
Keep it short and to the point. 1.42. What is the difference between the highest and the lowest Female Labor Force(as % of total labor force) of Vietnam?
Offer a terse response. 0.09. 